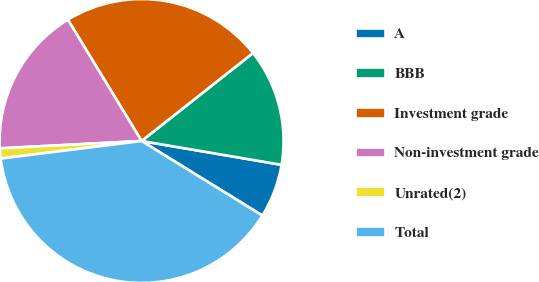<chart> <loc_0><loc_0><loc_500><loc_500><pie_chart><fcel>A<fcel>BBB<fcel>Investment grade<fcel>Non-investment grade<fcel>Unrated(2)<fcel>Total<nl><fcel>6.12%<fcel>13.32%<fcel>23.06%<fcel>17.13%<fcel>1.15%<fcel>39.22%<nl></chart> 